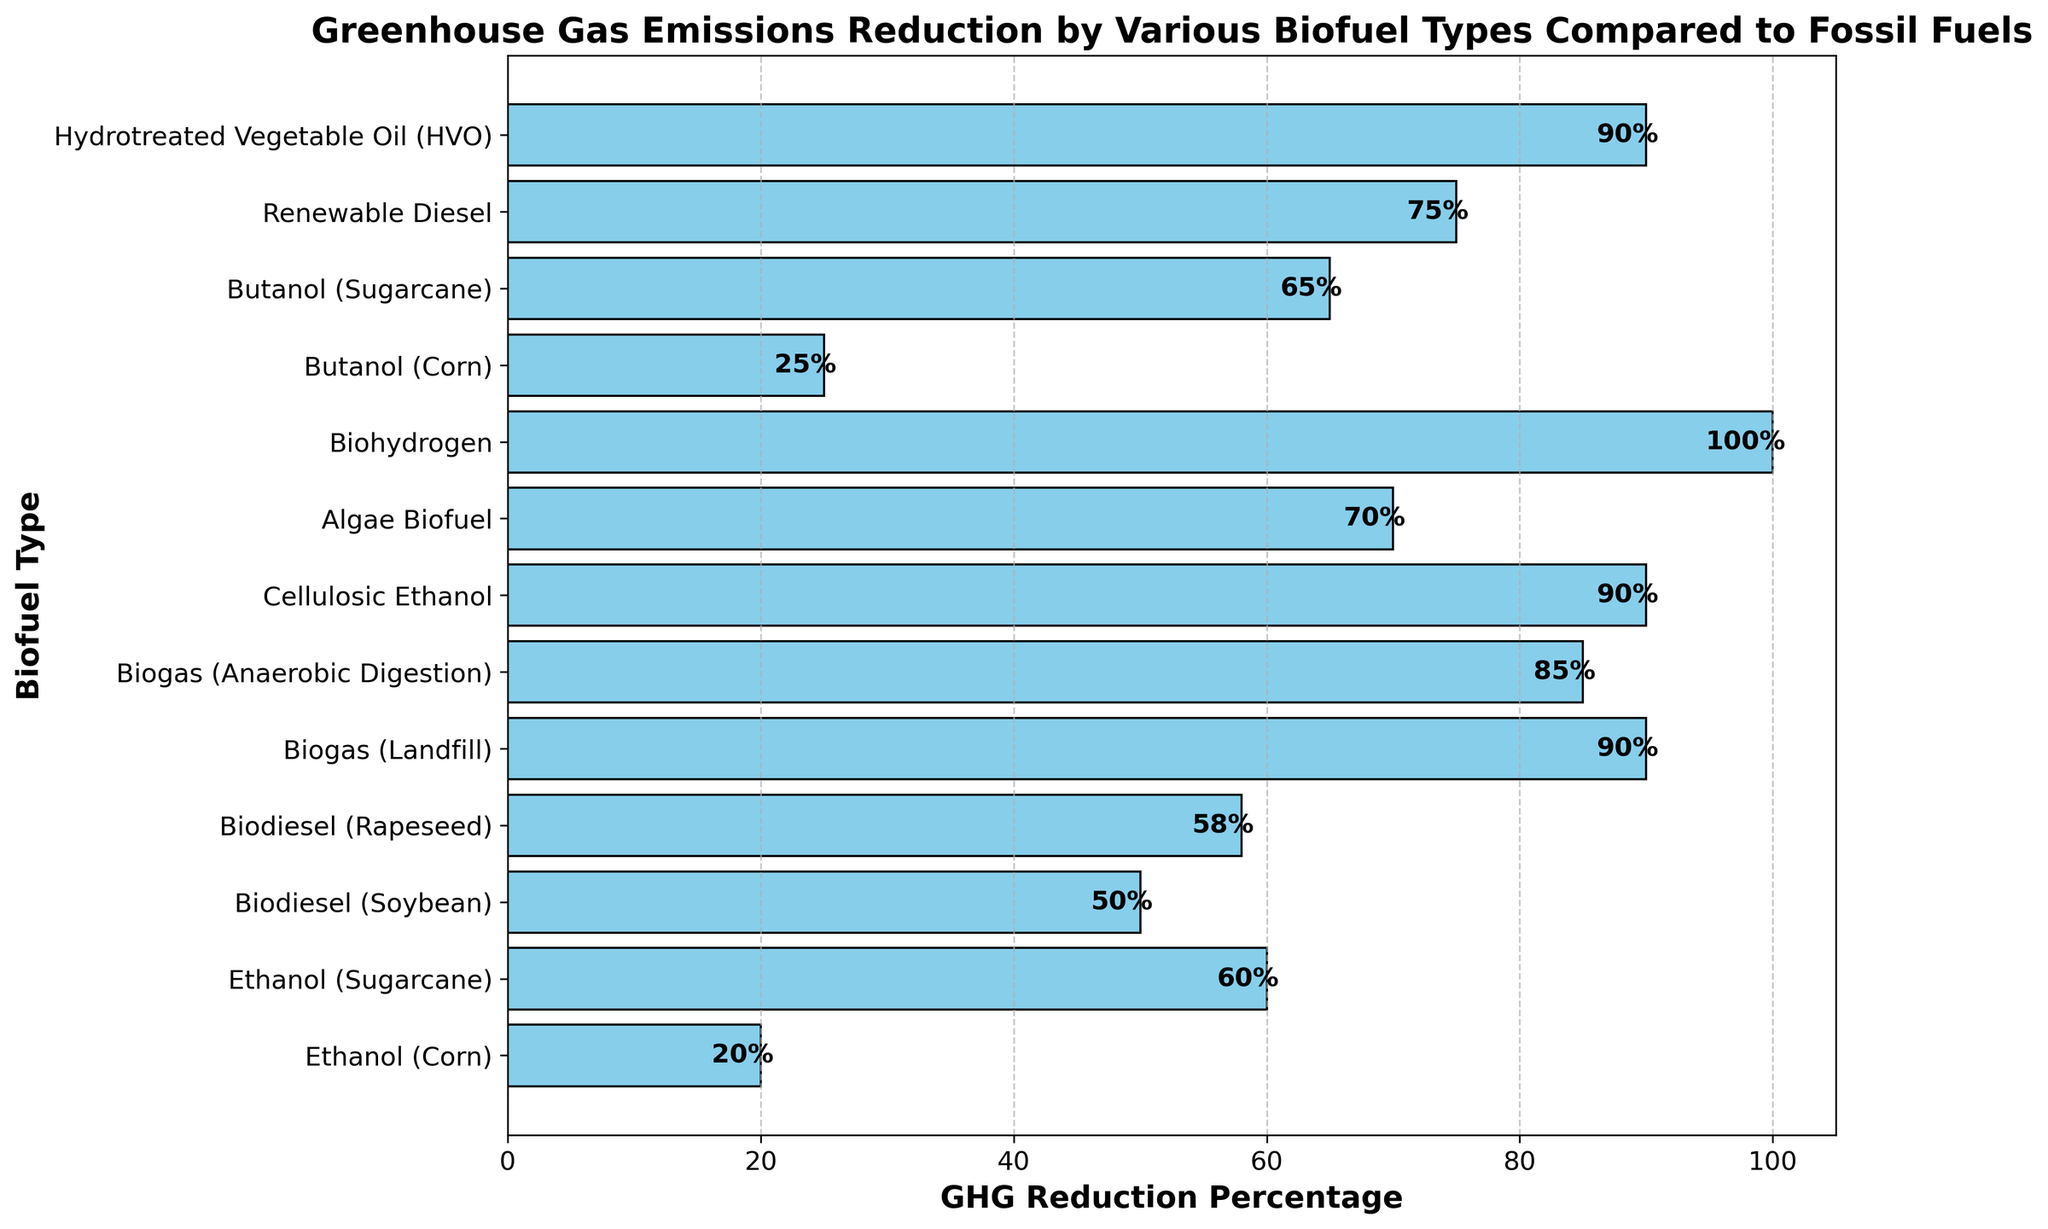Which biofuel type achieves the highest reduction in GHG emissions? By looking at the bar lengths, the longest bar corresponds to Biohydrogen with a GHG reduction percentage of 100%.
Answer: Biohydrogen Which biofuel types achieve at least 90% GHG reduction? The bars for GHG reduction percentages 90% and above are checked, identifying Biogas (Landfill), Cellulosic Ethanol, Hydrotreated Vegetable Oil (HVO), and Biohydrogen.
Answer: Biogas (Landfill), Cellulosic Ethanol, Hydrotreated Vegetable Oil (HVO), Biohydrogen What's the GHG reduction difference between Ethanol (Sugarcane) and Butanol (Corn)? Ethanol (Sugarcane) has a reduction of 60%, and Butanol (Corn) has 25%. The difference is calculated as 60% - 25%.
Answer: 35% Which biofuel type has a lower GHG reduction percentage, Biodiesel (Rapeseed) or Ethanol (Corn)? Comparing the bar lengths of Biodiesel (Rapeseed) with 58% reduction and Ethanol (Corn) with 20% reduction, Ethanol (Corn) has a lower percentage.
Answer: Ethanol (Corn) Are there more biofuel types with GHG reductions below or above 50%? Counting the number of biofuel types above and below 50%, there are 3 below (Ethanol (Corn), Butanol (Corn), Biodiesel (Soybean)) and 10 above.
Answer: Above 50% What is the average GHG reduction for Biodiesel types? Biodiesel types are Soybean (50%) and Rapeseed (58%). The average is calculated as (50% + 58%) / 2.
Answer: 54% Describe the visual difference between the bars for Biogas (Landfill) and Algae Biofuel. The bar for Biogas (Landfill) is longer (90%) compared to Algae Biofuel (70%) and is placed above Algae Biofuel in the plotted order.
Answer: Biogas (Landfill) bar is longer and above Which biofuel types have a GHG reduction percentage of exactly 90%? Checking the bars for exact 90% reduction, identifying Biogas (Landfill), Cellulosic Ethanol, and Hydrotreated Vegetable Oil (HVO).
Answer: Biogas (Landfill), Cellulosic Ethanol, Hydrotreated Vegetable Oil (HVO) Compare the GHG reduction percentages between Butanol (Sugarcane) and Ethanol (Sugarcane)? Ethanol (Sugarcane) has a 60% reduction while Butanol (Sugarcane) has 65%. Butanol (Sugarcane) has a slightly higher reduction.
Answer: Butanol (Sugarcane) is higher What is the combined GHG reduction of the two biofuel types with the smallest reductions? The smallest GHG reductions are Ethanol (Corn) at 20% and Butanol (Corn) at 25%. Their combined reduction is calculated as 20% + 25%.
Answer: 45% 